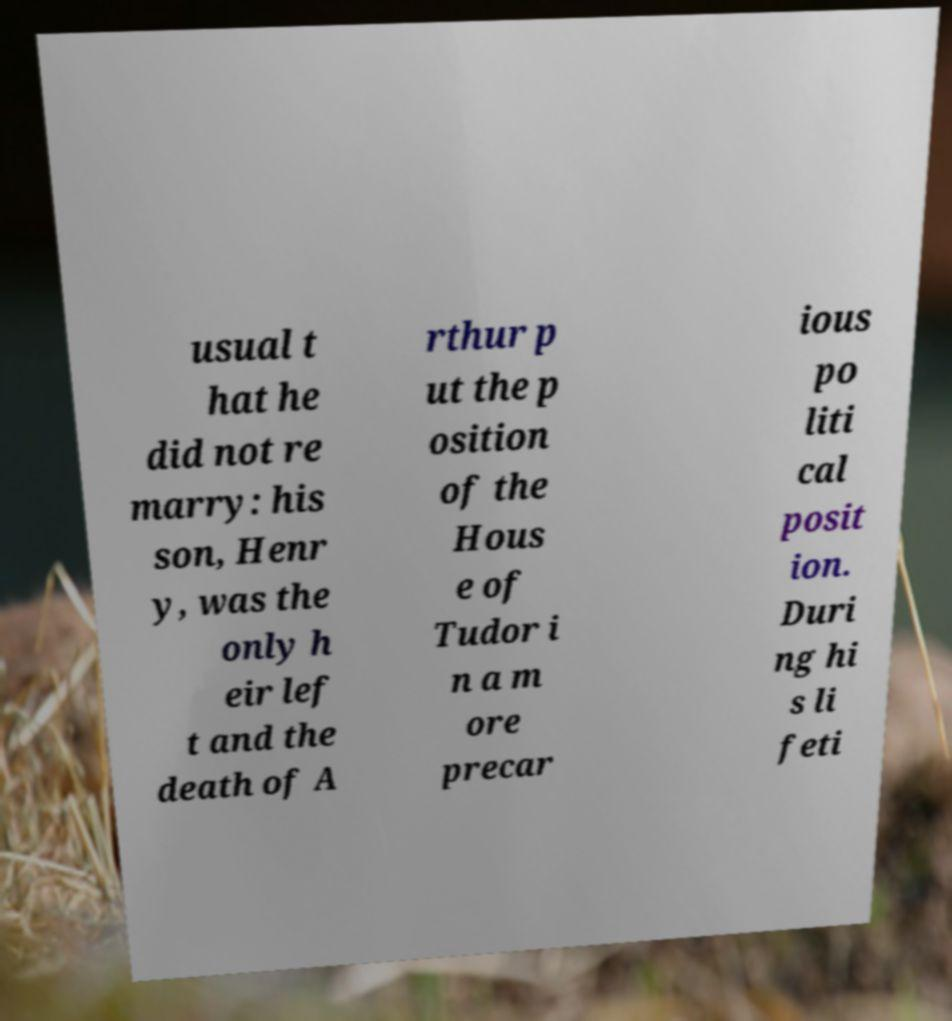I need the written content from this picture converted into text. Can you do that? usual t hat he did not re marry: his son, Henr y, was the only h eir lef t and the death of A rthur p ut the p osition of the Hous e of Tudor i n a m ore precar ious po liti cal posit ion. Duri ng hi s li feti 